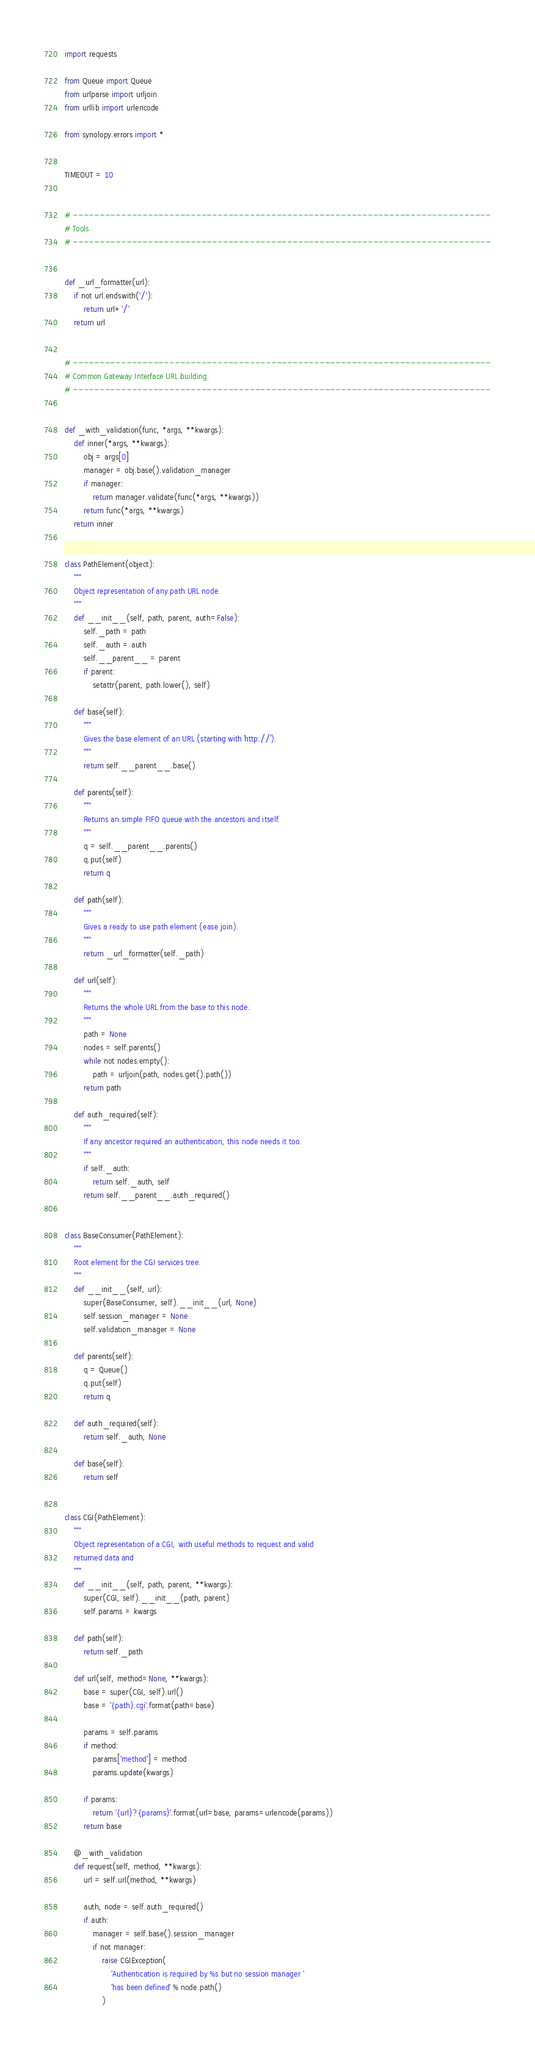<code> <loc_0><loc_0><loc_500><loc_500><_Python_>import requests

from Queue import Queue
from urlparse import urljoin
from urllib import urlencode

from synolopy.errors import *


TIMEOUT = 10


# ------------------------------------------------------------------------------
# Tools
# ------------------------------------------------------------------------------


def _url_formatter(url):
    if not url.endswith('/'):
        return url+'/'
    return url


# ------------------------------------------------------------------------------
# Common Gateway Interface URL building.
# ------------------------------------------------------------------------------


def _with_validation(func, *args, **kwargs):
    def inner(*args, **kwargs):
        obj = args[0]
        manager = obj.base().validation_manager
        if manager:
            return manager.validate(func(*args, **kwargs))
        return func(*args, **kwargs)
    return inner


class PathElement(object):
    """
    Object representation of any path URL node.
    """
    def __init__(self, path, parent, auth=False):
        self._path = path
        self._auth = auth
        self.__parent__ = parent
        if parent:
            setattr(parent, path.lower(), self)

    def base(self):
        """
        Gives the base element of an URL (starting with `http://`).
        """
        return self.__parent__.base()

    def parents(self):
        """
        Returns an simple FIFO queue with the ancestors and itself.
        """
        q = self.__parent__.parents()
        q.put(self)
        return q

    def path(self):
        """
        Gives a ready to use path element (ease join).
        """
        return _url_formatter(self._path)

    def url(self):
        """
        Returns the whole URL from the base to this node.
        """
        path = None
        nodes = self.parents()
        while not nodes.empty():
            path = urljoin(path, nodes.get().path())
        return path

    def auth_required(self):
        """
        If any ancestor required an authentication, this node needs it too.
        """
        if self._auth:
            return self._auth, self
        return self.__parent__.auth_required()


class BaseConsumer(PathElement):
    """
    Root element for the CGI services tree.
    """
    def __init__(self, url):
        super(BaseConsumer, self).__init__(url, None)
        self.session_manager = None
        self.validation_manager = None

    def parents(self):
        q = Queue()
        q.put(self)
        return q

    def auth_required(self):
        return self._auth, None

    def base(self):
        return self


class CGI(PathElement):
    """
    Object representation of a CGI, with useful methods to request and valid
    returned data and
    """
    def __init__(self, path, parent, **kwargs):
        super(CGI, self).__init__(path, parent)
        self.params = kwargs

    def path(self):
        return self._path

    def url(self, method=None, **kwargs):
        base = super(CGI, self).url()
        base = '{path}.cgi'.format(path=base)

        params = self.params
        if method:
            params['method'] = method
            params.update(kwargs)

        if params:
            return '{url}?{params}'.format(url=base, params=urlencode(params))
        return base

    @_with_validation
    def request(self, method, **kwargs):
        url = self.url(method, **kwargs)

        auth, node = self.auth_required()
        if auth:
            manager = self.base().session_manager
            if not manager:
                raise CGIException(
                    'Authentication is required by %s but no session manager '
                    'has been defined' % node.path()
                )</code> 